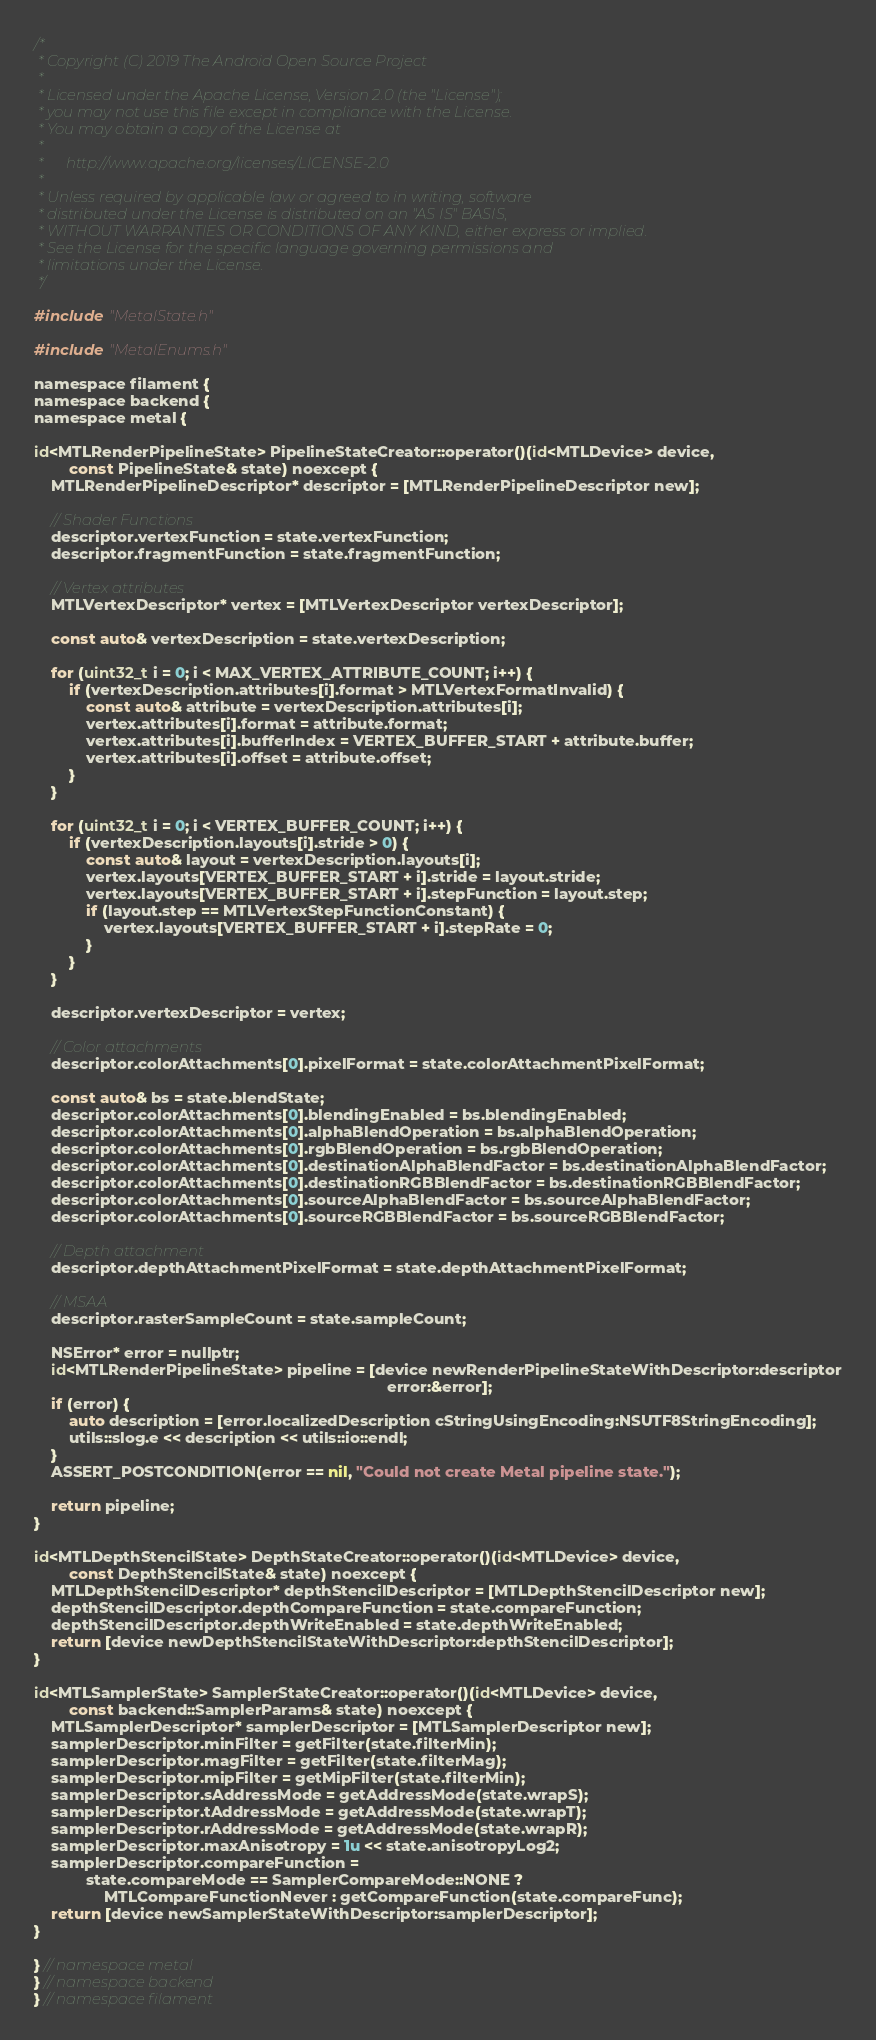Convert code to text. <code><loc_0><loc_0><loc_500><loc_500><_ObjectiveC_>/*
 * Copyright (C) 2019 The Android Open Source Project
 *
 * Licensed under the Apache License, Version 2.0 (the "License");
 * you may not use this file except in compliance with the License.
 * You may obtain a copy of the License at
 *
 *      http://www.apache.org/licenses/LICENSE-2.0
 *
 * Unless required by applicable law or agreed to in writing, software
 * distributed under the License is distributed on an "AS IS" BASIS,
 * WITHOUT WARRANTIES OR CONDITIONS OF ANY KIND, either express or implied.
 * See the License for the specific language governing permissions and
 * limitations under the License.
 */

#include "MetalState.h"

#include "MetalEnums.h"

namespace filament {
namespace backend {
namespace metal {

id<MTLRenderPipelineState> PipelineStateCreator::operator()(id<MTLDevice> device,
        const PipelineState& state) noexcept {
    MTLRenderPipelineDescriptor* descriptor = [MTLRenderPipelineDescriptor new];

    // Shader Functions
    descriptor.vertexFunction = state.vertexFunction;
    descriptor.fragmentFunction = state.fragmentFunction;

    // Vertex attributes
    MTLVertexDescriptor* vertex = [MTLVertexDescriptor vertexDescriptor];

    const auto& vertexDescription = state.vertexDescription;

    for (uint32_t i = 0; i < MAX_VERTEX_ATTRIBUTE_COUNT; i++) {
        if (vertexDescription.attributes[i].format > MTLVertexFormatInvalid) {
            const auto& attribute = vertexDescription.attributes[i];
            vertex.attributes[i].format = attribute.format;
            vertex.attributes[i].bufferIndex = VERTEX_BUFFER_START + attribute.buffer;
            vertex.attributes[i].offset = attribute.offset;
        }
    }

    for (uint32_t i = 0; i < VERTEX_BUFFER_COUNT; i++) {
        if (vertexDescription.layouts[i].stride > 0) {
            const auto& layout = vertexDescription.layouts[i];
            vertex.layouts[VERTEX_BUFFER_START + i].stride = layout.stride;
            vertex.layouts[VERTEX_BUFFER_START + i].stepFunction = layout.step;
            if (layout.step == MTLVertexStepFunctionConstant) {
                vertex.layouts[VERTEX_BUFFER_START + i].stepRate = 0;
            }
        }
    }

    descriptor.vertexDescriptor = vertex;

    // Color attachments
    descriptor.colorAttachments[0].pixelFormat = state.colorAttachmentPixelFormat;

    const auto& bs = state.blendState;
    descriptor.colorAttachments[0].blendingEnabled = bs.blendingEnabled;
    descriptor.colorAttachments[0].alphaBlendOperation = bs.alphaBlendOperation;
    descriptor.colorAttachments[0].rgbBlendOperation = bs.rgbBlendOperation;
    descriptor.colorAttachments[0].destinationAlphaBlendFactor = bs.destinationAlphaBlendFactor;
    descriptor.colorAttachments[0].destinationRGBBlendFactor = bs.destinationRGBBlendFactor;
    descriptor.colorAttachments[0].sourceAlphaBlendFactor = bs.sourceAlphaBlendFactor;
    descriptor.colorAttachments[0].sourceRGBBlendFactor = bs.sourceRGBBlendFactor;

    // Depth attachment
    descriptor.depthAttachmentPixelFormat = state.depthAttachmentPixelFormat;

    // MSAA
    descriptor.rasterSampleCount = state.sampleCount;

    NSError* error = nullptr;
    id<MTLRenderPipelineState> pipeline = [device newRenderPipelineStateWithDescriptor:descriptor
                                                                                 error:&error];
    if (error) {
        auto description = [error.localizedDescription cStringUsingEncoding:NSUTF8StringEncoding];
        utils::slog.e << description << utils::io::endl;
    }
    ASSERT_POSTCONDITION(error == nil, "Could not create Metal pipeline state.");

    return pipeline;
}

id<MTLDepthStencilState> DepthStateCreator::operator()(id<MTLDevice> device,
        const DepthStencilState& state) noexcept {
    MTLDepthStencilDescriptor* depthStencilDescriptor = [MTLDepthStencilDescriptor new];
    depthStencilDescriptor.depthCompareFunction = state.compareFunction;
    depthStencilDescriptor.depthWriteEnabled = state.depthWriteEnabled;
    return [device newDepthStencilStateWithDescriptor:depthStencilDescriptor];
}

id<MTLSamplerState> SamplerStateCreator::operator()(id<MTLDevice> device,
        const backend::SamplerParams& state) noexcept {
    MTLSamplerDescriptor* samplerDescriptor = [MTLSamplerDescriptor new];
    samplerDescriptor.minFilter = getFilter(state.filterMin);
    samplerDescriptor.magFilter = getFilter(state.filterMag);
    samplerDescriptor.mipFilter = getMipFilter(state.filterMin);
    samplerDescriptor.sAddressMode = getAddressMode(state.wrapS);
    samplerDescriptor.tAddressMode = getAddressMode(state.wrapT);
    samplerDescriptor.rAddressMode = getAddressMode(state.wrapR);
    samplerDescriptor.maxAnisotropy = 1u << state.anisotropyLog2;
    samplerDescriptor.compareFunction =
            state.compareMode == SamplerCompareMode::NONE ?
                MTLCompareFunctionNever : getCompareFunction(state.compareFunc);
    return [device newSamplerStateWithDescriptor:samplerDescriptor];
}

} // namespace metal
} // namespace backend
} // namespace filament
</code> 